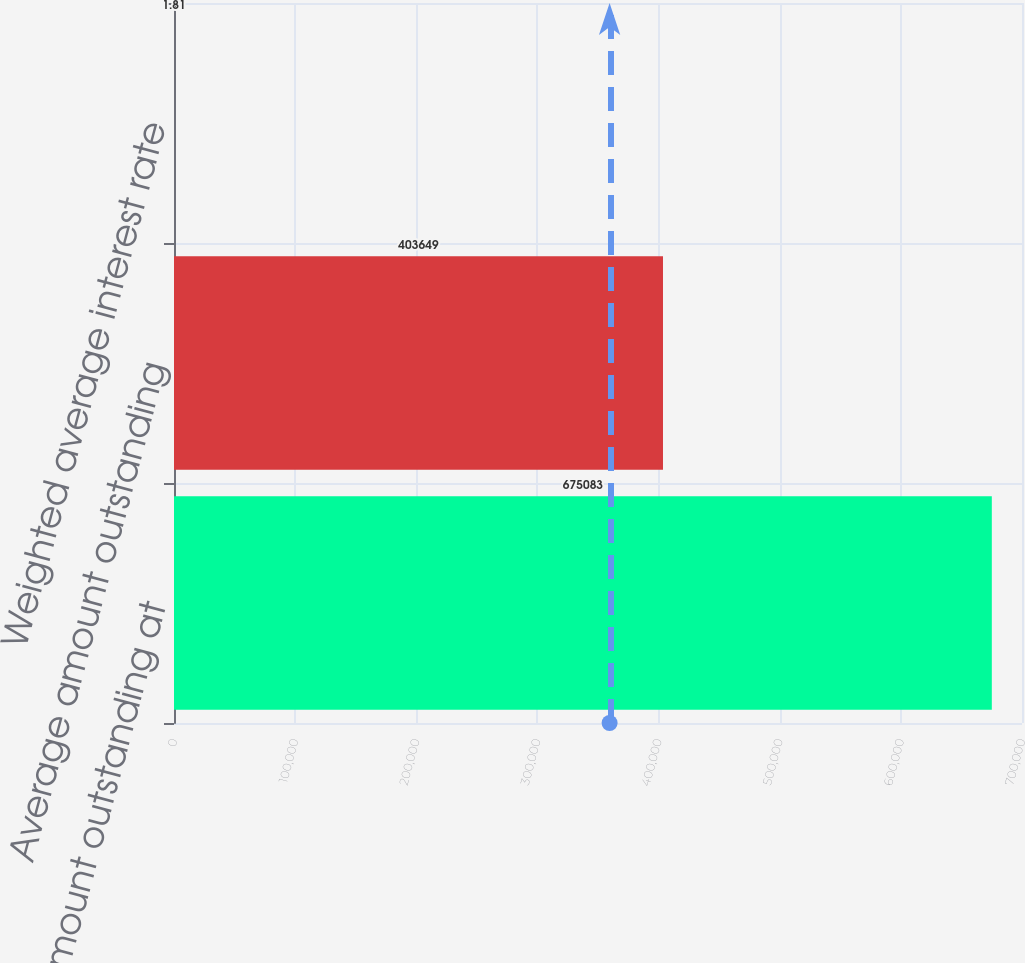<chart> <loc_0><loc_0><loc_500><loc_500><bar_chart><fcel>Maximum amount outstanding at<fcel>Average amount outstanding<fcel>Weighted average interest rate<nl><fcel>675083<fcel>403649<fcel>1.81<nl></chart> 